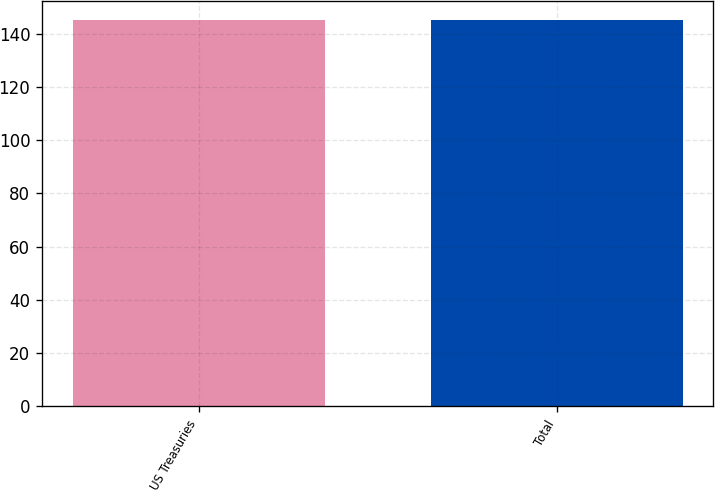<chart> <loc_0><loc_0><loc_500><loc_500><bar_chart><fcel>US Treasuries<fcel>Total<nl><fcel>145<fcel>145.1<nl></chart> 